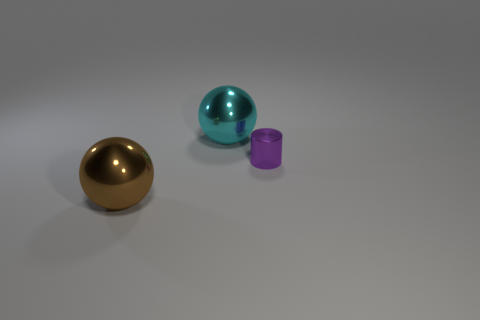Are there any other things that have the same size as the purple metallic thing?
Your answer should be very brief. No. Is there a big brown object that has the same shape as the large cyan metal thing?
Provide a short and direct response. Yes. There is a metal sphere that is the same size as the cyan metal object; what is its color?
Ensure brevity in your answer.  Brown. There is a big metallic thing in front of the sphere behind the tiny thing; what is its color?
Your answer should be very brief. Brown. There is a large object that is behind the brown object; is it the same color as the shiny cylinder?
Ensure brevity in your answer.  No. There is a big metal thing that is to the left of the sphere that is behind the metallic object to the left of the big cyan object; what shape is it?
Keep it short and to the point. Sphere. What number of big brown objects are in front of the ball that is left of the big cyan shiny sphere?
Your answer should be compact. 0. Does the large brown ball have the same material as the tiny purple cylinder?
Provide a short and direct response. Yes. How many large brown shiny things are in front of the large metal thing to the left of the sphere behind the brown thing?
Keep it short and to the point. 0. What is the color of the big shiny thing that is in front of the tiny purple metallic object?
Provide a short and direct response. Brown. 